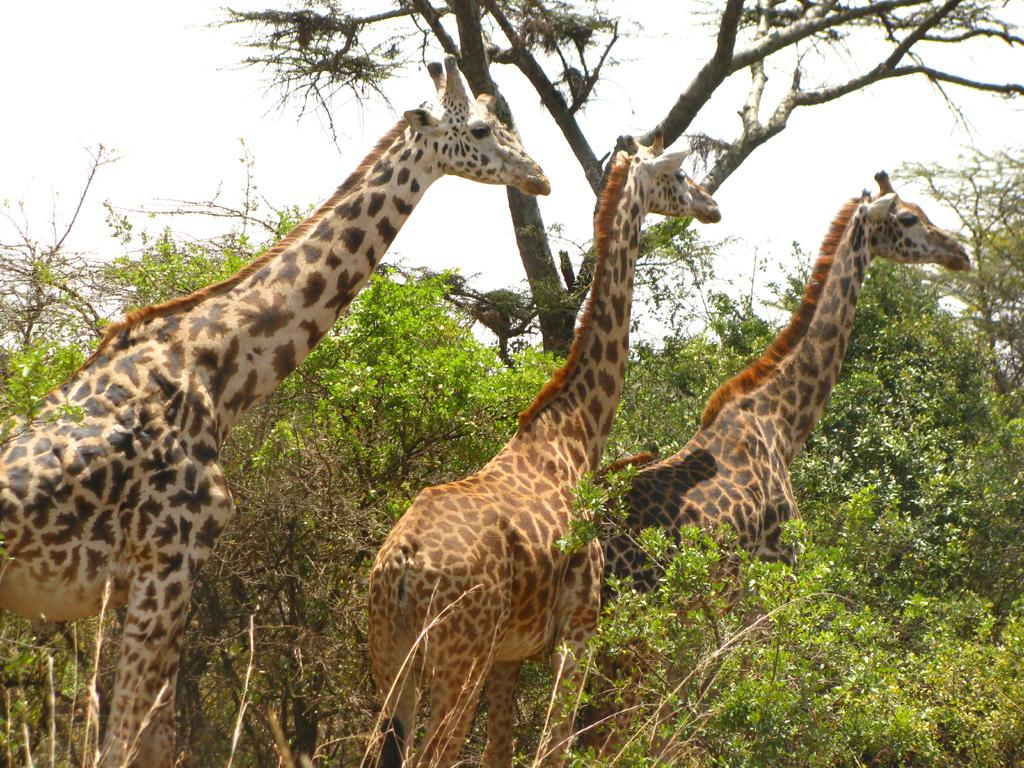How many giraffes are in the image? There are 3 giraffes in the image. What are the giraffes doing in the image? The giraffes are standing in the image. In which direction are the giraffes facing? The giraffes are facing towards the right. What type of vegetation can be seen in the image? There are trees in the image. What color of paint is being used by the woman in the image? There is no woman present in the image, and therefore no paint or painting activity can be observed. 